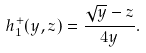Convert formula to latex. <formula><loc_0><loc_0><loc_500><loc_500>h _ { 1 } ^ { + } ( y , z ) = \frac { \sqrt { y } - z } { 4 y } .</formula> 